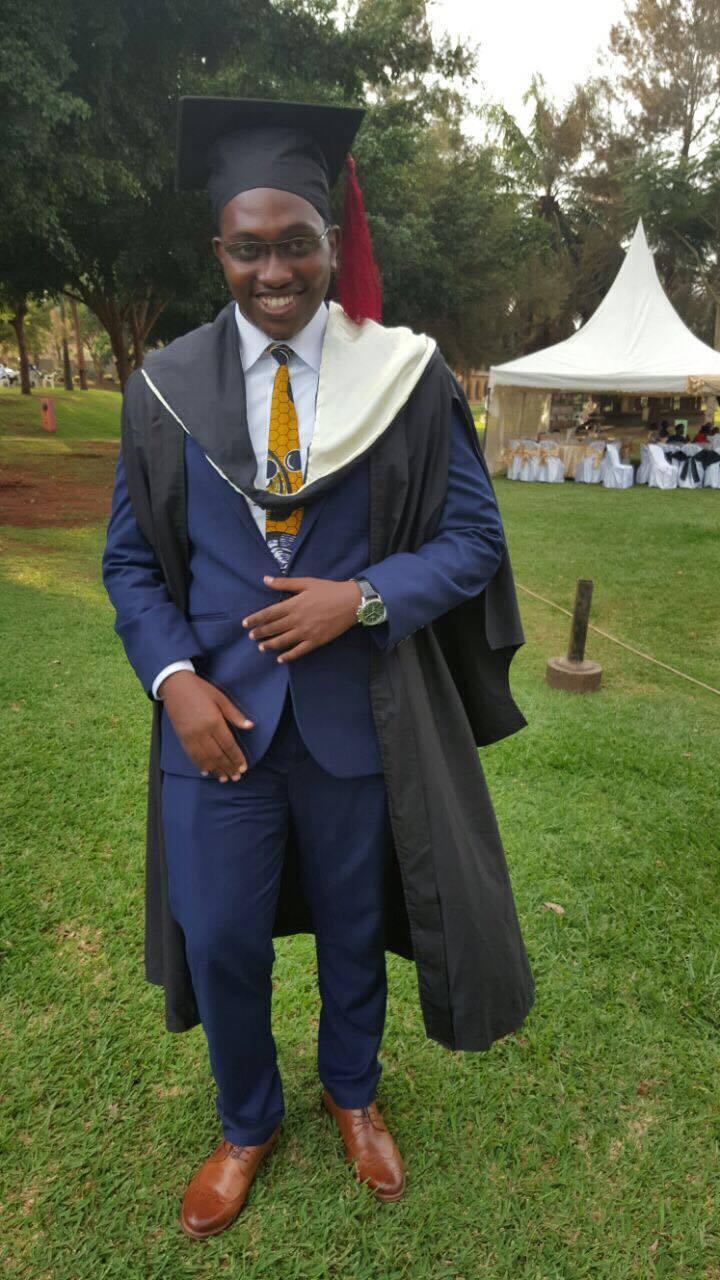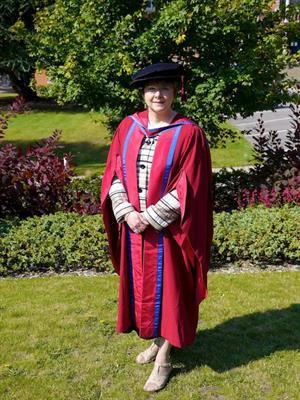The first image is the image on the left, the second image is the image on the right. For the images shown, is this caption "Two people, one man and one woman, wearing graduation gowns and caps, each a different style, are seen facing front in full length photos." true? Answer yes or no. Yes. The first image is the image on the left, the second image is the image on the right. Evaluate the accuracy of this statement regarding the images: "No graduate wears glasses, and the graduate in the right image is a male, while the graduate in the left image is female.". Is it true? Answer yes or no. No. 